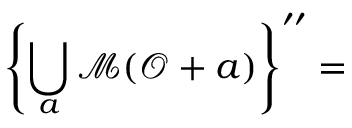<formula> <loc_0><loc_0><loc_500><loc_500>\left \{ \bigcup _ { a } \mathcal { M } ( \mathcal { O } + a ) \right \} ^ { \prime \prime } =</formula> 